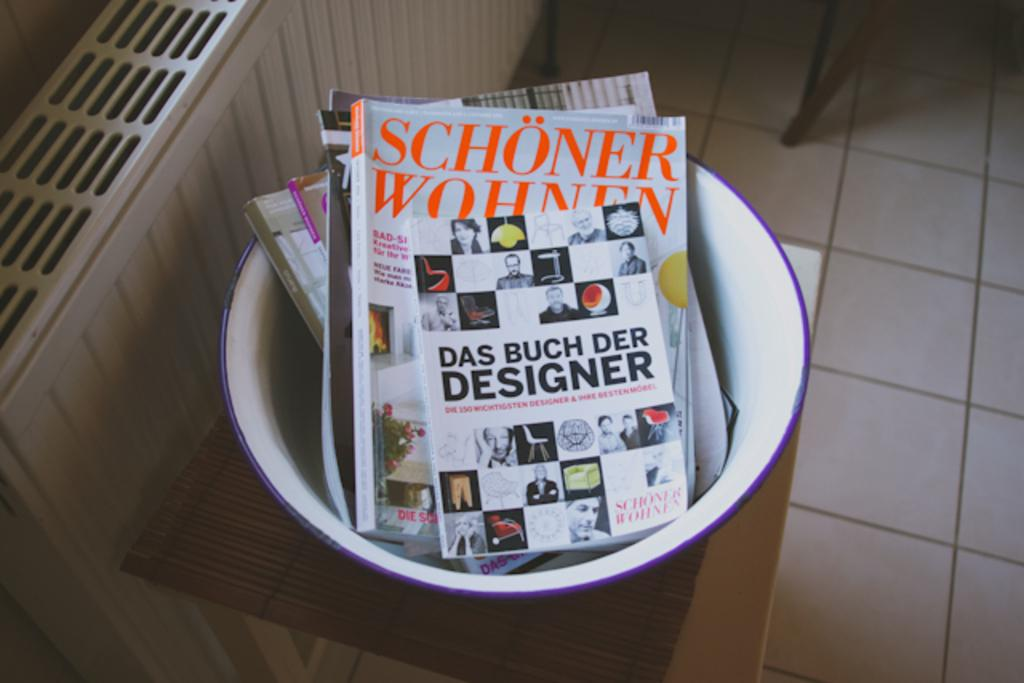What is the unusual placement of the books in the image? The books are in a bowl in the image. Where is the bowl with books located? The bowl is on a stool in the image. What is the stool resting on? The stool is on the floor in the image. What can be seen on the left side of the image? There is an object on the left side of the image. What type of rings can be seen on the books in the image? There are no rings present on the books in the image. 